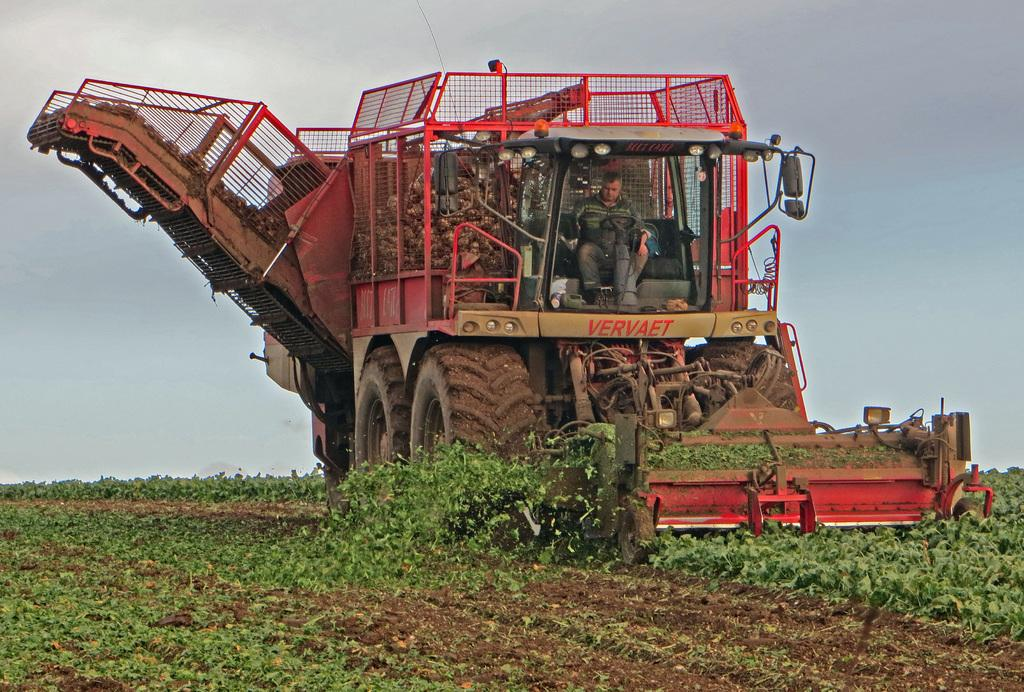What is the person in the image doing? The person is riding a tractor in the image. What is the purpose of the tractor in the image? The tractor is being used to cut grass in the image. What is the grass being cut on? The grass is on the surface of mud in the image. What can be seen in the background of the image? There is sky visible in the background of the image. Is the person's aunt holding an umbrella while they are riding the tractor? There is no mention of an aunt or an umbrella in the image, so we cannot answer that question. 